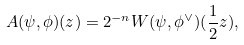Convert formula to latex. <formula><loc_0><loc_0><loc_500><loc_500>A ( \psi , \phi ) ( z ) = 2 ^ { - n } W ( \psi , \phi ^ { \vee } ) ( \frac { 1 } { 2 } z ) ,</formula> 